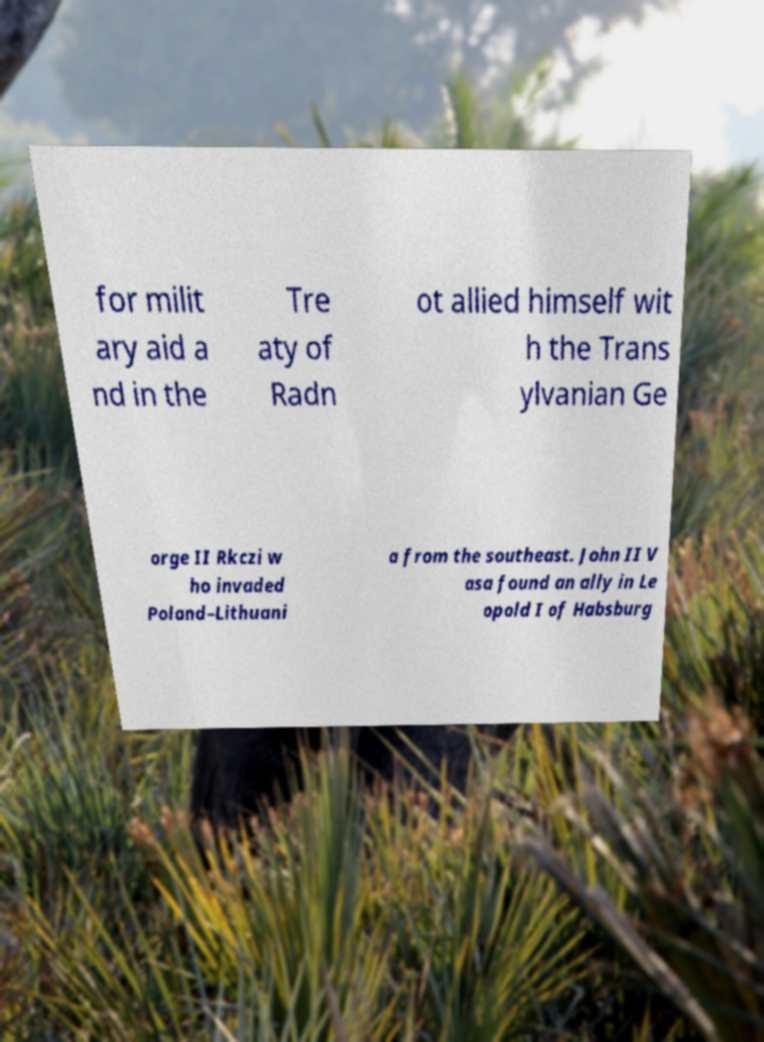Can you read and provide the text displayed in the image?This photo seems to have some interesting text. Can you extract and type it out for me? for milit ary aid a nd in the Tre aty of Radn ot allied himself wit h the Trans ylvanian Ge orge II Rkczi w ho invaded Poland–Lithuani a from the southeast. John II V asa found an ally in Le opold I of Habsburg 